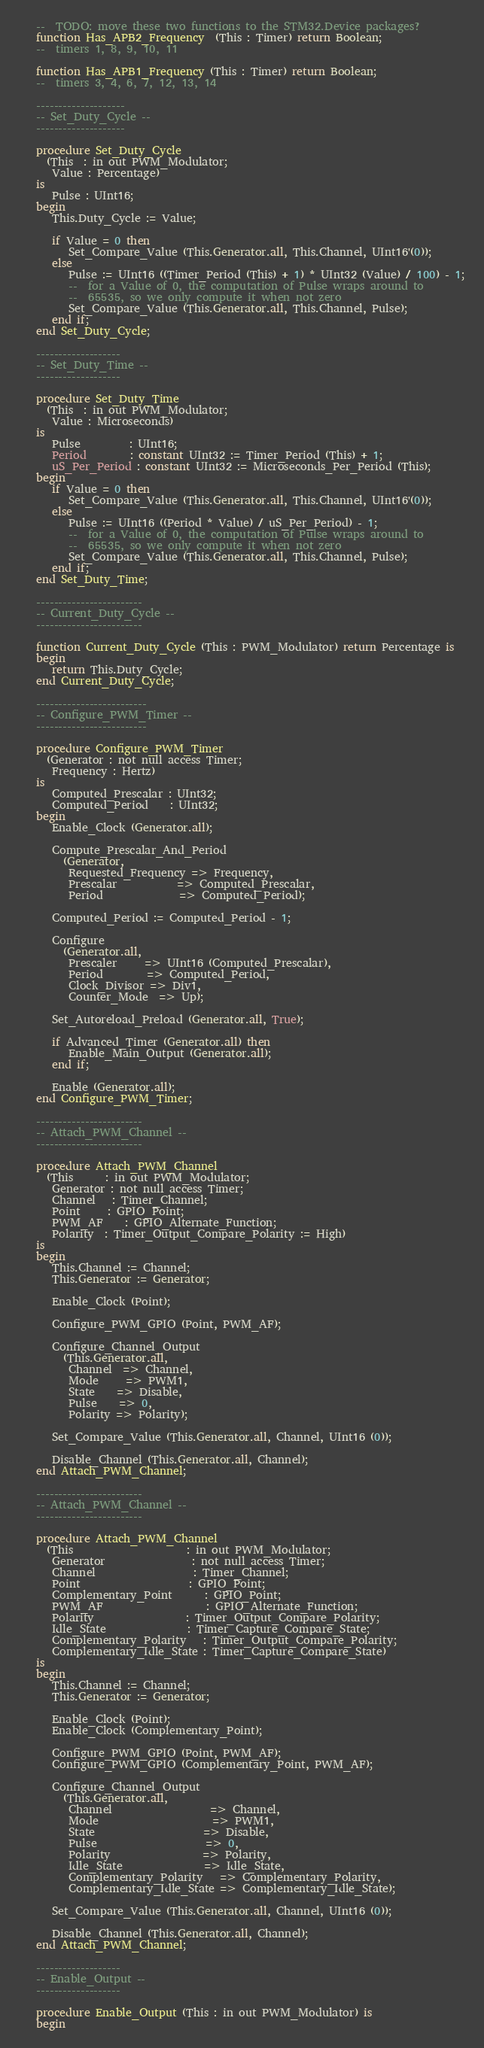<code> <loc_0><loc_0><loc_500><loc_500><_Ada_>
   --  TODO: move these two functions to the STM32.Device packages?
   function Has_APB2_Frequency  (This : Timer) return Boolean;
   --  timers 1, 8, 9, 10, 11

   function Has_APB1_Frequency (This : Timer) return Boolean;
   --  timers 3, 4, 6, 7, 12, 13, 14

   --------------------
   -- Set_Duty_Cycle --
   --------------------

   procedure Set_Duty_Cycle
     (This  : in out PWM_Modulator;
      Value : Percentage)
   is
      Pulse : UInt16;
   begin
      This.Duty_Cycle := Value;

      if Value = 0 then
         Set_Compare_Value (This.Generator.all, This.Channel, UInt16'(0));
      else
         Pulse := UInt16 ((Timer_Period (This) + 1) * UInt32 (Value) / 100) - 1;
         --  for a Value of 0, the computation of Pulse wraps around to
         --  65535, so we only compute it when not zero
         Set_Compare_Value (This.Generator.all, This.Channel, Pulse);
      end if;
   end Set_Duty_Cycle;

   -------------------
   -- Set_Duty_Time --
   -------------------

   procedure Set_Duty_Time
     (This  : in out PWM_Modulator;
      Value : Microseconds)
   is
      Pulse         : UInt16;
      Period        : constant UInt32 := Timer_Period (This) + 1;
      uS_Per_Period : constant UInt32 := Microseconds_Per_Period (This);
   begin
      if Value = 0 then
         Set_Compare_Value (This.Generator.all, This.Channel, UInt16'(0));
      else
         Pulse := UInt16 ((Period * Value) / uS_Per_Period) - 1;
         --  for a Value of 0, the computation of Pulse wraps around to
         --  65535, so we only compute it when not zero
         Set_Compare_Value (This.Generator.all, This.Channel, Pulse);
      end if;
   end Set_Duty_Time;

   ------------------------
   -- Current_Duty_Cycle --
   ------------------------

   function Current_Duty_Cycle (This : PWM_Modulator) return Percentage is
   begin
      return This.Duty_Cycle;
   end Current_Duty_Cycle;

   -------------------------
   -- Configure_PWM_Timer --
   -------------------------

   procedure Configure_PWM_Timer
     (Generator : not null access Timer;
      Frequency : Hertz)
   is
      Computed_Prescalar : UInt32;
      Computed_Period    : UInt32;
   begin
      Enable_Clock (Generator.all);

      Compute_Prescalar_And_Period
        (Generator,
         Requested_Frequency => Frequency,
         Prescalar           => Computed_Prescalar,
         Period              => Computed_Period);

      Computed_Period := Computed_Period - 1;

      Configure
        (Generator.all,
         Prescaler     => UInt16 (Computed_Prescalar),
         Period        => Computed_Period,
         Clock_Divisor => Div1,
         Counter_Mode  => Up);

      Set_Autoreload_Preload (Generator.all, True);

      if Advanced_Timer (Generator.all) then
         Enable_Main_Output (Generator.all);
      end if;

      Enable (Generator.all);
   end Configure_PWM_Timer;

   ------------------------
   -- Attach_PWM_Channel --
   ------------------------

   procedure Attach_PWM_Channel
     (This      : in out PWM_Modulator;
      Generator : not null access Timer;
      Channel   : Timer_Channel;
      Point     : GPIO_Point;
      PWM_AF    : GPIO_Alternate_Function;
      Polarity  : Timer_Output_Compare_Polarity := High)
   is
   begin
      This.Channel := Channel;
      This.Generator := Generator;

      Enable_Clock (Point);

      Configure_PWM_GPIO (Point, PWM_AF);

      Configure_Channel_Output
        (This.Generator.all,
         Channel  => Channel,
         Mode     => PWM1,
         State    => Disable,
         Pulse    => 0,
         Polarity => Polarity);

      Set_Compare_Value (This.Generator.all, Channel, UInt16 (0));

      Disable_Channel (This.Generator.all, Channel);
   end Attach_PWM_Channel;

   ------------------------
   -- Attach_PWM_Channel --
   ------------------------

   procedure Attach_PWM_Channel
     (This                     : in out PWM_Modulator;
      Generator                : not null access Timer;
      Channel                  : Timer_Channel;
      Point                    : GPIO_Point;
      Complementary_Point      : GPIO_Point;
      PWM_AF                   : GPIO_Alternate_Function;
      Polarity                 : Timer_Output_Compare_Polarity;
      Idle_State               : Timer_Capture_Compare_State;
      Complementary_Polarity   : Timer_Output_Compare_Polarity;
      Complementary_Idle_State : Timer_Capture_Compare_State)
   is
   begin
      This.Channel := Channel;
      This.Generator := Generator;

      Enable_Clock (Point);
      Enable_Clock (Complementary_Point);

      Configure_PWM_GPIO (Point, PWM_AF);
      Configure_PWM_GPIO (Complementary_Point, PWM_AF);

      Configure_Channel_Output
        (This.Generator.all,
         Channel                  => Channel,
         Mode                     => PWM1,
         State                    => Disable,
         Pulse                    => 0,
         Polarity                 => Polarity,
         Idle_State               => Idle_State,
         Complementary_Polarity   => Complementary_Polarity,
         Complementary_Idle_State => Complementary_Idle_State);

      Set_Compare_Value (This.Generator.all, Channel, UInt16 (0));

      Disable_Channel (This.Generator.all, Channel);
   end Attach_PWM_Channel;

   -------------------
   -- Enable_Output --
   -------------------

   procedure Enable_Output (This : in out PWM_Modulator) is
   begin</code> 